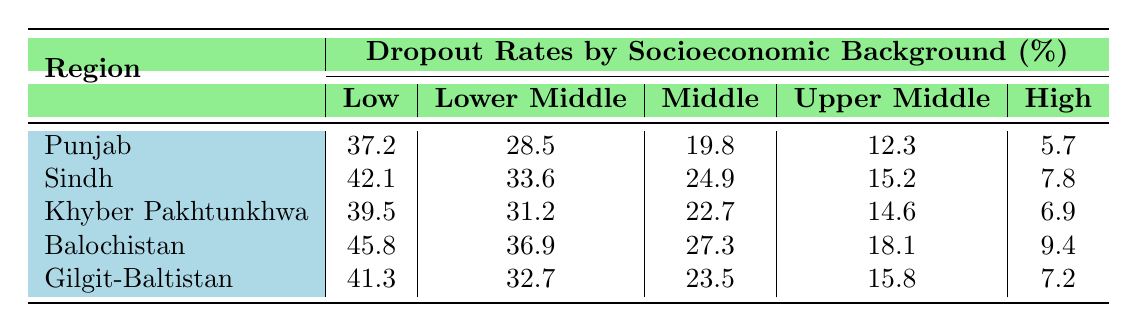What region has the highest dropout rate for low-income students? By looking at the first column under "Low," the dropout rates listed for each region are 37.2 in Punjab, 42.1 in Sindh, 39.5 in Khyber Pakhtunkhwa, 45.8 in Balochistan, and 41.3 in Gilgit-Baltistan. The highest value is 45.8 for Balochistan.
Answer: Balochistan What is the dropout rate for upper middle-income students in Punjab? The dropout rate for upper middle-income students in Punjab is listed in the table under the corresponding region and socioeconomic background. It is 12.3.
Answer: 12.3 What are the dropout rates for high-income students in Sindh and Khyber Pakhtunkhwa combined? The dropout rates for high-income students are 7.8 in Sindh and 6.9 in Khyber Pakhtunkhwa. Adding these gives 7.8 + 6.9 = 14.7.
Answer: 14.7 Which socioeconomic background has the lowest dropout rate across all regions? The lowest dropout rates for each socioeconomic background are 5.7 for high income, 12.3 for upper middle income, 19.8 for middle income, 28.5 for lower middle income, and 37.2 for low income. The lowest of these is 5.7 for high income.
Answer: High income Is the dropout rate for middle-income students in Gilgit-Baltistan higher than that in Khyber Pakhtunkhwa? The dropout rates are 23.5 for Gilgit-Baltistan and 22.7 for Khyber Pakhtunkhwa. Since 23.5 is greater than 22.7, the statement is true.
Answer: Yes What is the average dropout rate for lower middle-income students across all regions? The dropout rates for lower middle-income students across the regions are 28.5 (Punjab), 33.6 (Sindh), 31.2 (Khyber Pakhtunkhwa), 36.9 (Balochistan), and 32.7 (Gilgit-Baltistan). The sum is 28.5 + 33.6 + 31.2 + 36.9 + 32.7 = 162. The average is 162/5 = 32.4.
Answer: 32.4 Which region showed the highest disparity in dropout rates for low-income students compared to high-income students? To find this, we look at the dropout rates for low and high-income students in each region: Punjab (37.2 - 5.7 = 31.5), Sindh (42.1 - 7.8 = 34.3), Khyber Pakhtunkhwa (39.5 - 6.9 = 32.6), Balochistan (45.8 - 9.4 = 36.4), and Gilgit-Baltistan (41.3 - 7.2 = 34.1). The highest disparity is in Balochistan with a difference of 36.4.
Answer: Balochistan In which region do female students exhibit the highest dropout rates in lower middle income? The dropout rates for lower middle-income female students across regions are not given in this table, but if we assume they follow the same pattern as male rates, they would be the same. Thus, we can refer to the values: 28.5 in Punjab, 33.6 in Sindh, 31.2 in Khyber Pakhtunkhwa, 36.9 in Balochistan, and 32.7 in Gilgit-Baltistan. The highest rate is 36.9 in Balochistan.
Answer: Balochistan What is the total dropout rate for low-income students in all regions combined? The dropout rates for low-income students are 37.2 (Punjab), 42.1 (Sindh), 39.5 (Khyber Pakhtunkhwa), 45.8 (Balochistan), and 41.3 (Gilgit-Baltistan). The total is 37.2 + 42.1 + 39.5 + 45.8 + 41.3 = 205.9.
Answer: 205.9 